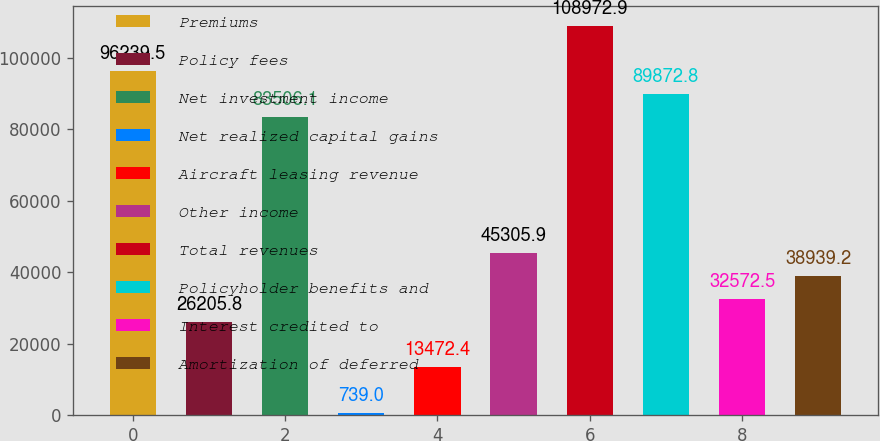Convert chart to OTSL. <chart><loc_0><loc_0><loc_500><loc_500><bar_chart><fcel>Premiums<fcel>Policy fees<fcel>Net investment income<fcel>Net realized capital gains<fcel>Aircraft leasing revenue<fcel>Other income<fcel>Total revenues<fcel>Policyholder benefits and<fcel>Interest credited to<fcel>Amortization of deferred<nl><fcel>96239.5<fcel>26205.8<fcel>83506.1<fcel>739<fcel>13472.4<fcel>45305.9<fcel>108973<fcel>89872.8<fcel>32572.5<fcel>38939.2<nl></chart> 